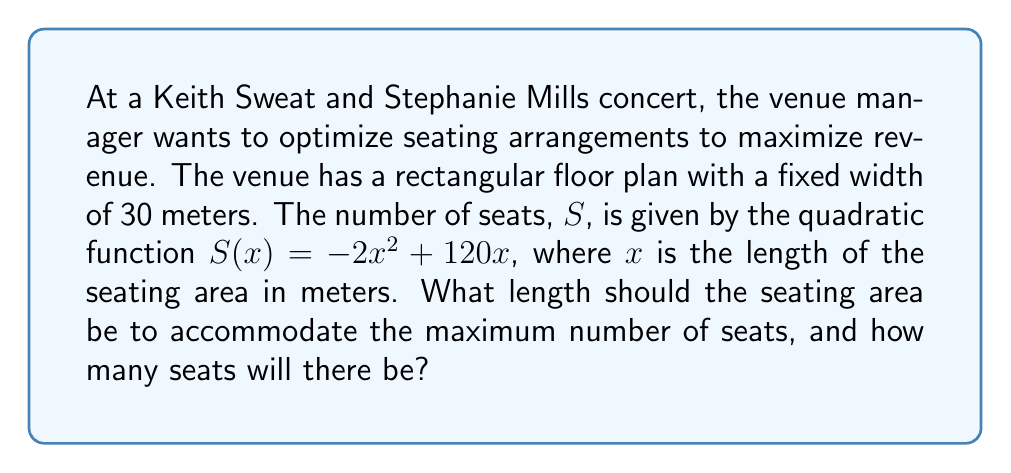Provide a solution to this math problem. To solve this problem, we'll follow these steps:

1) The quadratic function for the number of seats is:
   $S(x) = -2x^2 + 120x$

2) To find the maximum number of seats, we need to find the vertex of this parabola. For a quadratic function in the form $f(x) = ax^2 + bx + c$, the x-coordinate of the vertex is given by $x = -\frac{b}{2a}$.

3) In our case, $a = -2$ and $b = 120$. So:
   $x = -\frac{120}{2(-2)} = -\frac{120}{-4} = 30$

4) This means the seating area should be 30 meters long to accommodate the maximum number of seats.

5) To find the maximum number of seats, we substitute $x = 30$ into our original function:

   $S(30) = -2(30)^2 + 120(30)$
   $= -2(900) + 3600$
   $= -1800 + 3600$
   $= 1800$

Therefore, the maximum number of seats is 1800.
Answer: 30 meters long; 1800 seats 